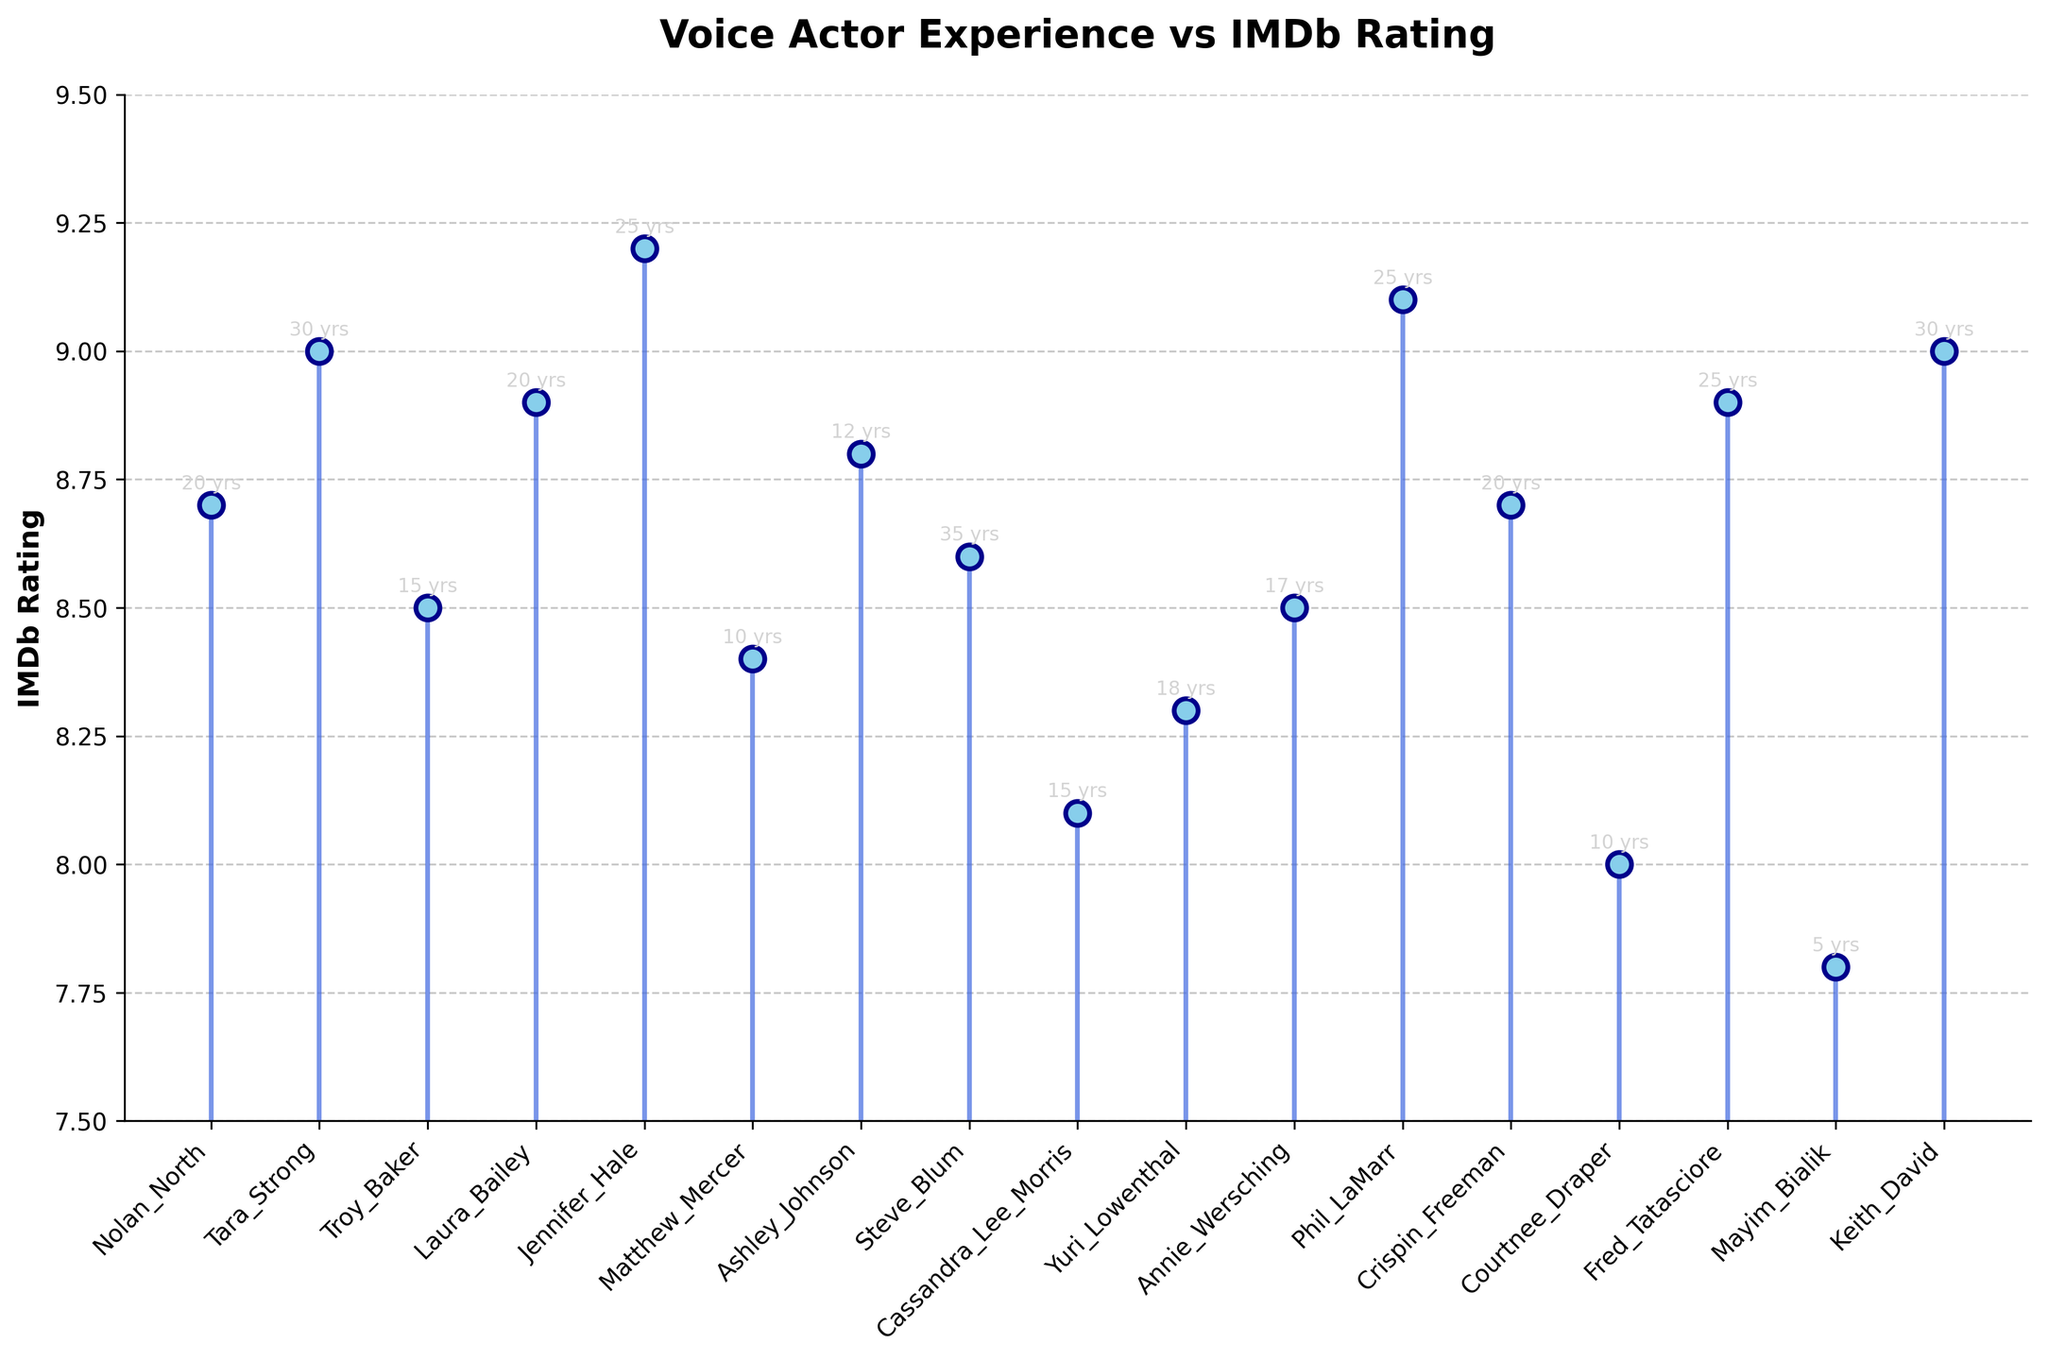What's the highest IMDb rating among the voice actors? The plot shows various IMDb ratings for each voice actor. Simply identify the highest point on the vertical axis, which is 9.2.
Answer: 9.2 How many voice actors have an IMDb rating of 9.0 or higher? The plot has markers at 9.0, 9.1, and 9.2. Count the voice actors corresponding to these ratings: Tara Strong, Jennifer Hale, Phil LaMarr, and Keith David, for a total of four.
Answer: 4 Which voice actor has the least experience, and what's their IMDb rating? Look at the annotations for years of experience; Mayim Bialik has the least with 5 years. Her IMDb rating is 7.8.
Answer: Mayim Bialik, 7.8 Who's the most experienced voice actor, and what's their IMDb rating? Look for the highest years of experience annotation; Steve Blum has the most with 35 years. His IMDb rating is 8.6.
Answer: Steve Blum, 8.6 What is the average IMDb rating of the voice actors with 20 years of experience? The actors are Nolan North, Laura Bailey, and Crispin Freeman with 20 years each. Their ratings are 8.7, 8.9, and 8.7. (8.7 + 8.9 + 8.7) / 3 results in an average of 8.76.
Answer: 8.76 How many voice actors have exactly 15 years of experience, and what are their IMDb ratings? Cassandra Lee Morris and Troy Baker both have 15 years. Their IMDb ratings are 8.1 and 8.5.
Answer: 2 (8.1, 8.5) Which voice actor with 25 years of experience has the highest IMDb rating? The actors with 25 years of experience are Jennifer Hale, Phil LaMarr, and Fred Tatasciore with ratings of 9.2, 9.1, and 8.9. Jennifer Hale has the highest at 9.2.
Answer: Jennifer Hale What is the range of IMDb ratings for voice actors with more than 20 years of experience? Identify the actors: Tara Strong (30 years, 9.0), Jennifer Hale (25 years, 9.2), Steve Blum (35 years, 8.6), Phil LaMarr (25 years, 9.1), Fred Tatasciore (25 years, 8.9), Keith David (30 years, 9.0). The highest rating is 9.2 and the lowest is 8.6. The range is 9.2 - 8.6 = 0.6.
Answer: 0.6 Which voice actor(s) have an IMDb rating exactly equal to the median rating on this plot? The IMDb ratings sorted are: 7.8, 8.0, 8.1, 8.3, 8.4, 8.5, 8.5, 8.6, 8.7, 8.7, 8.8, 8.9, 8.9, 9.0, 9.0, 9.1, 9.2. The middle value (median) is the 9th one, which is 8.7. The voice actors with 8.7 are Nolan North and Crispin Freeman.
Answer: Nolan North, Crispin Freeman What's the difference in IMDb rating between the voice actors with the least and most experience? The least experienced is Mayim Bialik with 7.8, and the most experienced is Steve Blum with 8.6. The difference is 8.6 - 7.8 = 0.8.
Answer: 0.8 